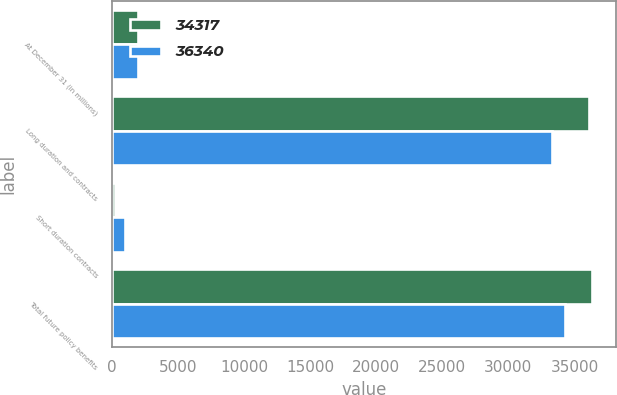<chart> <loc_0><loc_0><loc_500><loc_500><stacked_bar_chart><ecel><fcel>At December 31 (in millions)<fcel>Long duration and contracts<fcel>Short duration contracts<fcel>Total future policy benefits<nl><fcel>34317<fcel>2012<fcel>36121<fcel>219<fcel>36340<nl><fcel>36340<fcel>2011<fcel>33322<fcel>995<fcel>34317<nl></chart> 